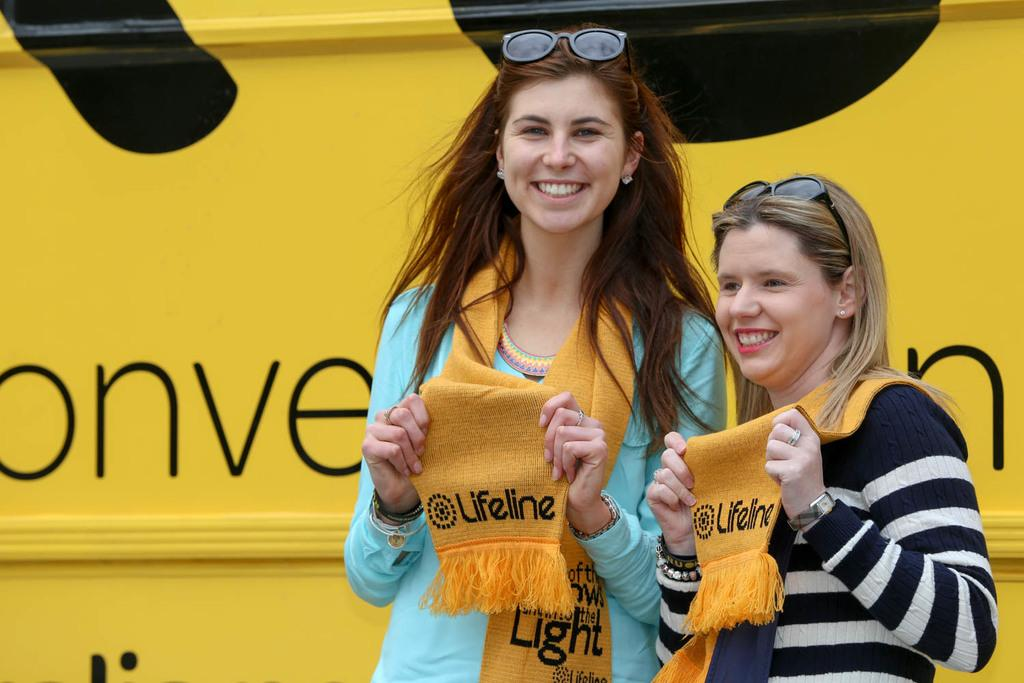How many people are in the image? There are two women in the image. What are the women doing in the image? The women are standing and smiling. What are the women holding in the image? The women are holding scarves. What can be seen in the background of the image? There is a board in the background of the image. What type of donkey can be seen in the image? There is no donkey present in the image. How old is the daughter of the woman in the image? There is no daughter mentioned or depicted in the image. 